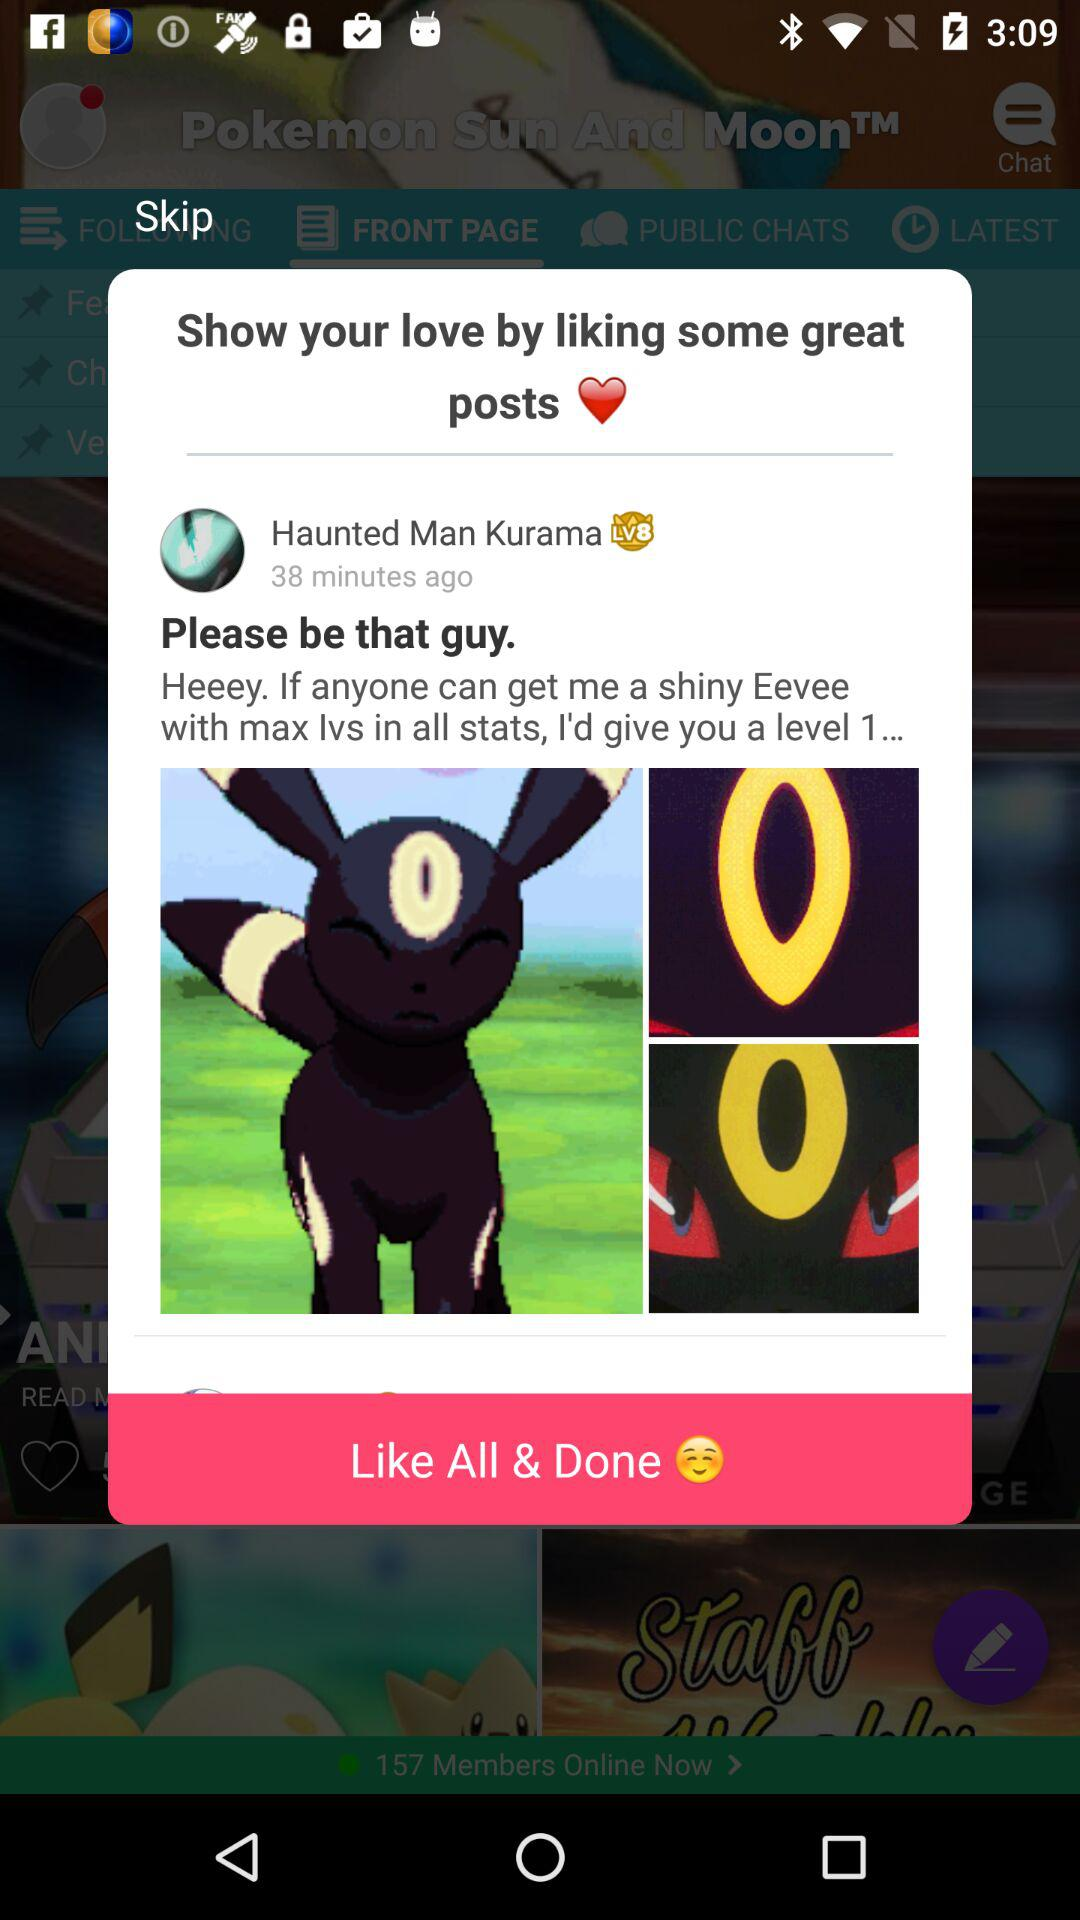How many minutes ago was the "Haunted Man Kurama" posted? The "Haunted Man Kurama" posted 38 minutes ago. 